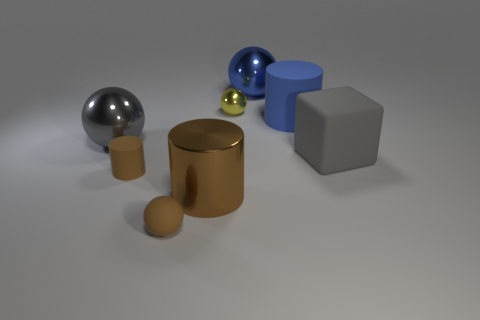Add 1 brown matte objects. How many objects exist? 9 Subtract all cylinders. How many objects are left? 5 Add 2 tiny cyan metal objects. How many tiny cyan metal objects exist? 2 Subtract 0 cyan cubes. How many objects are left? 8 Subtract all small red objects. Subtract all large blue things. How many objects are left? 6 Add 8 big balls. How many big balls are left? 10 